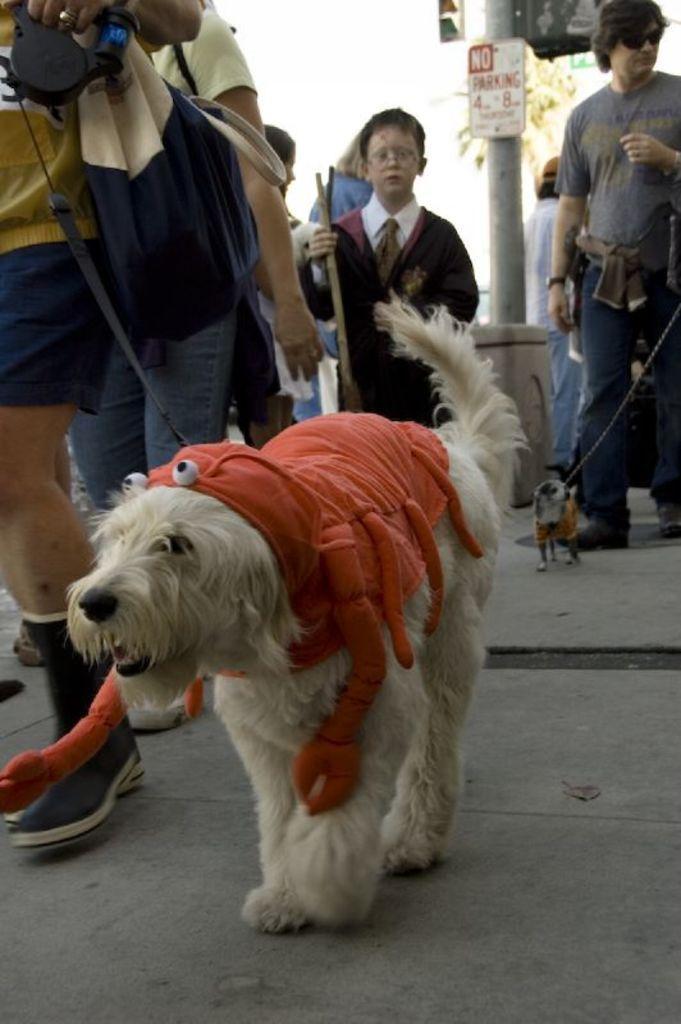In one or two sentences, can you explain what this image depicts? In this image I can see the group of people and the dogs. At the back there is a tree and the sky. 